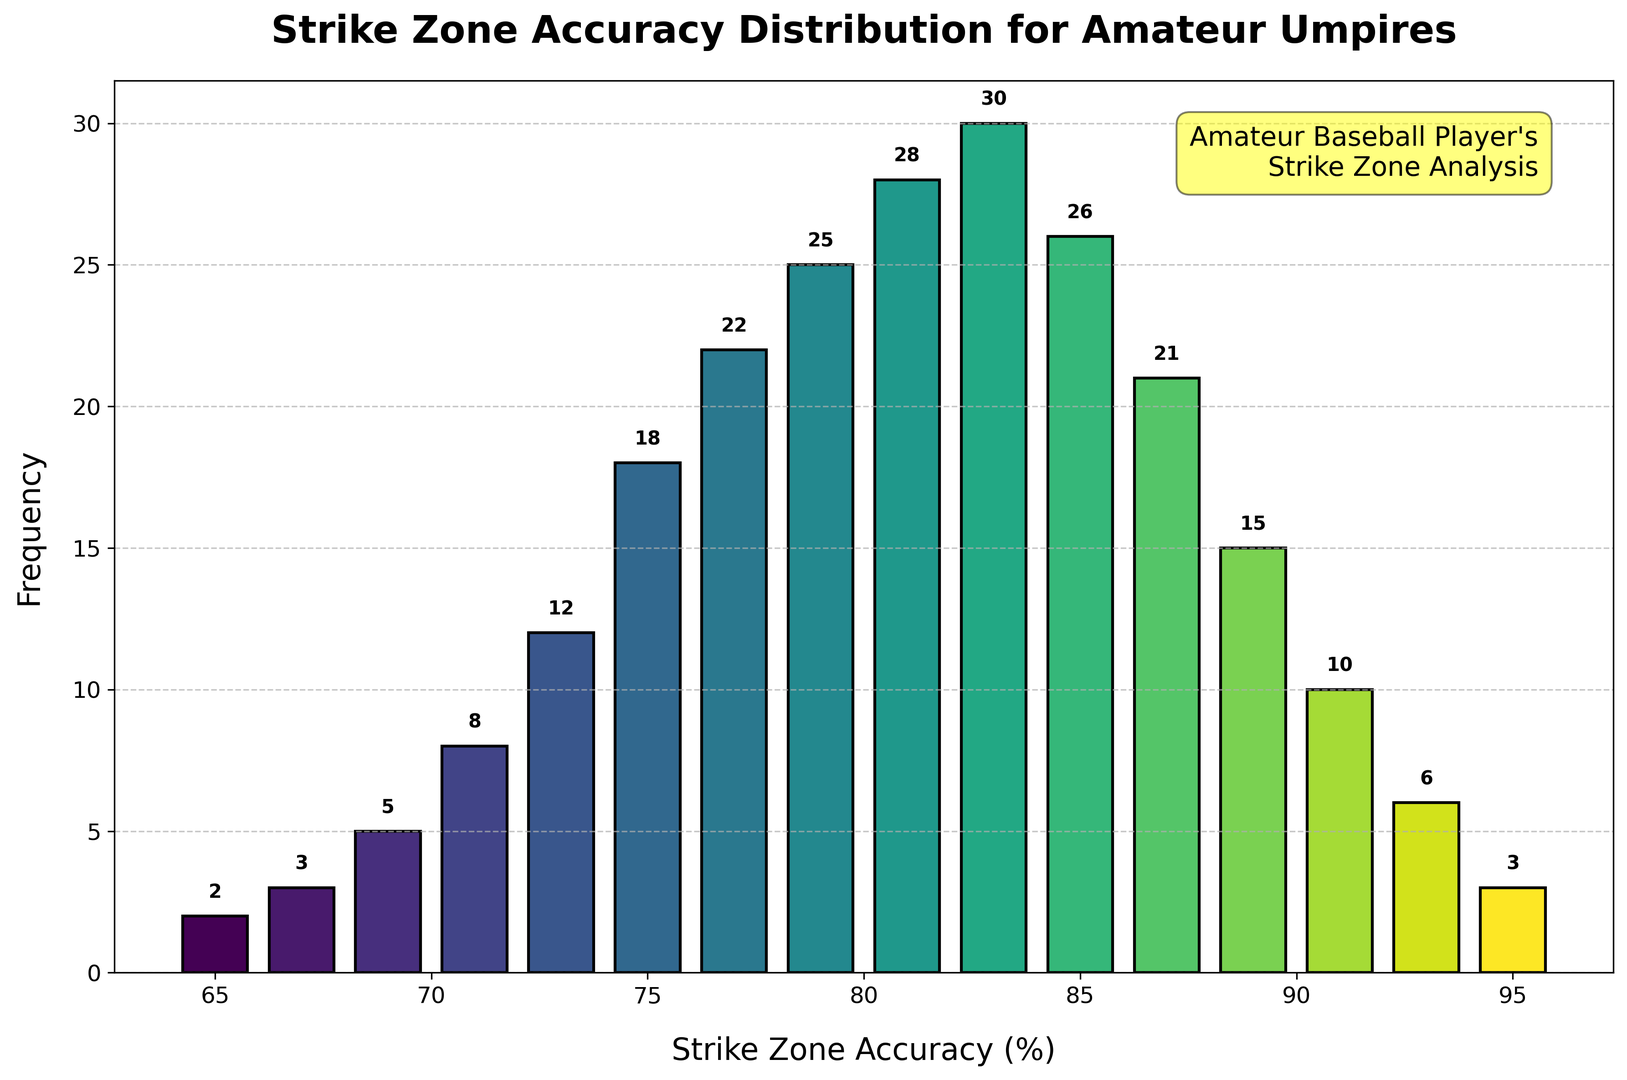What is the most common strike zone accuracy percentage among amateur umpires? The most common value is represented by the tallest bar in the histogram. The bar at 83% has the highest frequency of 30.
Answer: 83% How many umpires have a strike zone accuracy between 65% and 75%? Sum the frequencies for accuracy values 65%, 67%, 69%, 71%, 73%, and 75%: 2 + 3 + 5 + 8 + 12 + 18 = 48.
Answer: 48 What is the difference in frequency between umpires with 85% and 95% accuracy? Subtract the frequency at 95% accuracy (3) from the frequency at 85% accuracy (26): 26 - 3 = 23.
Answer: 23 Which strike zone accuracy percentage has a frequency equal to 6? Look for the accuracy percentage where the frequency value is 6. The 93% accuracy percentage has a frequency of 6.
Answer: 93% What is the average frequency of umpires with an accuracy percentage above 90%? The accuracy percentages above 90% are 91%, 93%, and 95% with frequencies 10, 6, and 3 respectively. Average frequency = (10 + 6 + 3) / 3 = 19 / 3 ≈ 6.33.
Answer: 6.33 How many umpires have a strike zone accuracy of 87% or higher? Sum the frequencies for accuracy values 87%, 89%, 91%, 93%, and 95%: 21 + 15 + 10 + 6 + 3 = 55.
Answer: 55 Is the number of umpires with strike zone accuracy less than 70% more than those with accuracy more than 90%? Sum the frequencies for acccuracy less than 70%: 2 + 3 + 5 = 10. Sum the frequencies for accuracy more than 90%: 10 + 6 + 3 = 19. Compare: 10 is less than 19.
Answer: No Among the accuracies of 75%, 79%, and 83%, which one has the highest frequency and what is the frequency? Compare the frequencies: 75% (18), 79% (25), and 83% (30). The highest is 83% with a frequency of 30.
Answer: 83%, 30 Which bar color is the darkest and what is the corresponding accuracy percentage? The histogram colors get darker as the accuracy percentage increases. The darkest bar corresponds to 95% accuracy.
Answer: 95% How does the frequency change as the accuracy rate increases from 81% to 85%? Identify the frequencies for these values: 81% (28), 83% (30), 85% (26). The frequency increases from 28 to 30 then decreases to 26.
Answer: Increases then decreases 